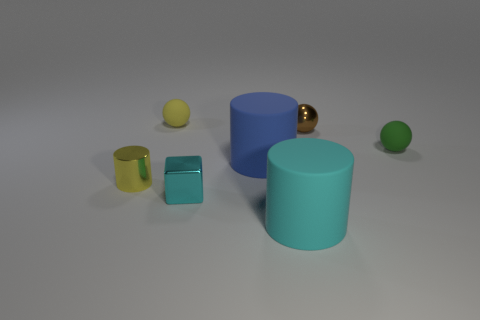What number of cyan things are matte objects or small metal balls?
Provide a succinct answer. 1. Does the shiny object that is behind the tiny yellow shiny cylinder have the same size as the rubber cylinder on the right side of the blue matte cylinder?
Keep it short and to the point. No. How many things are either metal blocks or metal cylinders?
Keep it short and to the point. 2. Is there a large rubber object that has the same shape as the tiny green matte thing?
Ensure brevity in your answer.  No. Are there fewer tiny spheres than shiny balls?
Give a very brief answer. No. Does the cyan matte object have the same shape as the small yellow metallic object?
Give a very brief answer. Yes. How many objects are either big yellow matte objects or tiny things left of the cyan matte cylinder?
Your answer should be very brief. 3. How many small yellow matte spheres are there?
Your response must be concise. 1. Are there any yellow metal things that have the same size as the cyan metal cube?
Keep it short and to the point. Yes. Is the number of big blue objects left of the blue rubber thing less than the number of big purple spheres?
Offer a terse response. No. 